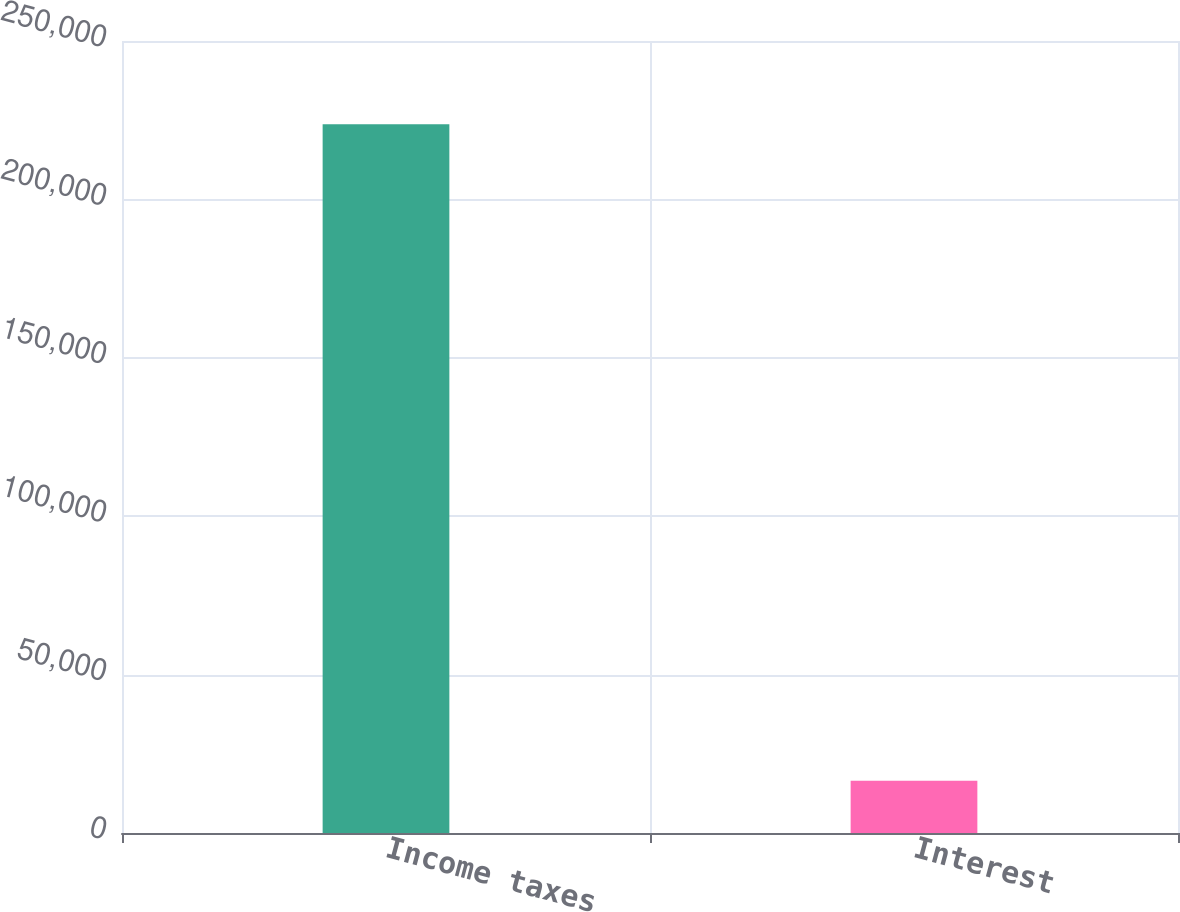Convert chart to OTSL. <chart><loc_0><loc_0><loc_500><loc_500><bar_chart><fcel>Income taxes<fcel>Interest<nl><fcel>223716<fcel>16492<nl></chart> 